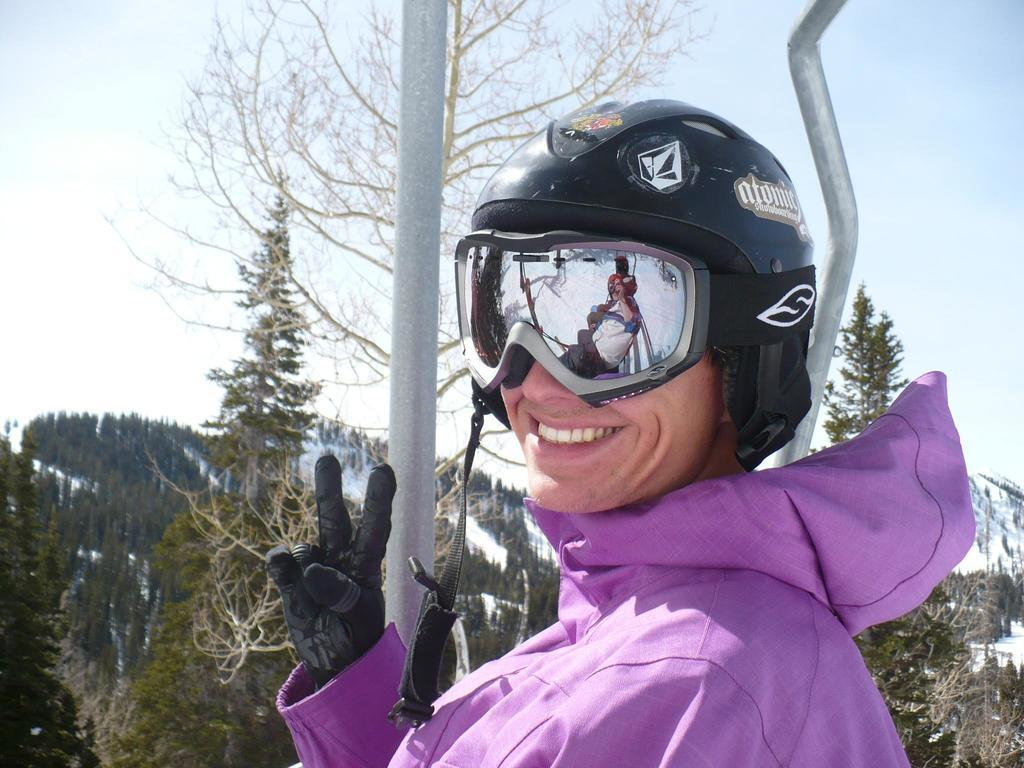What is present in the image? There is a person in the image. What can be seen in the background of the image? There are trees and the sky visible in the background of the image. What color of paint is being used by the person in the image? There is no paint or painting activity present in the image. How many cubs are visible in the image? There are no cubs present in the image. 